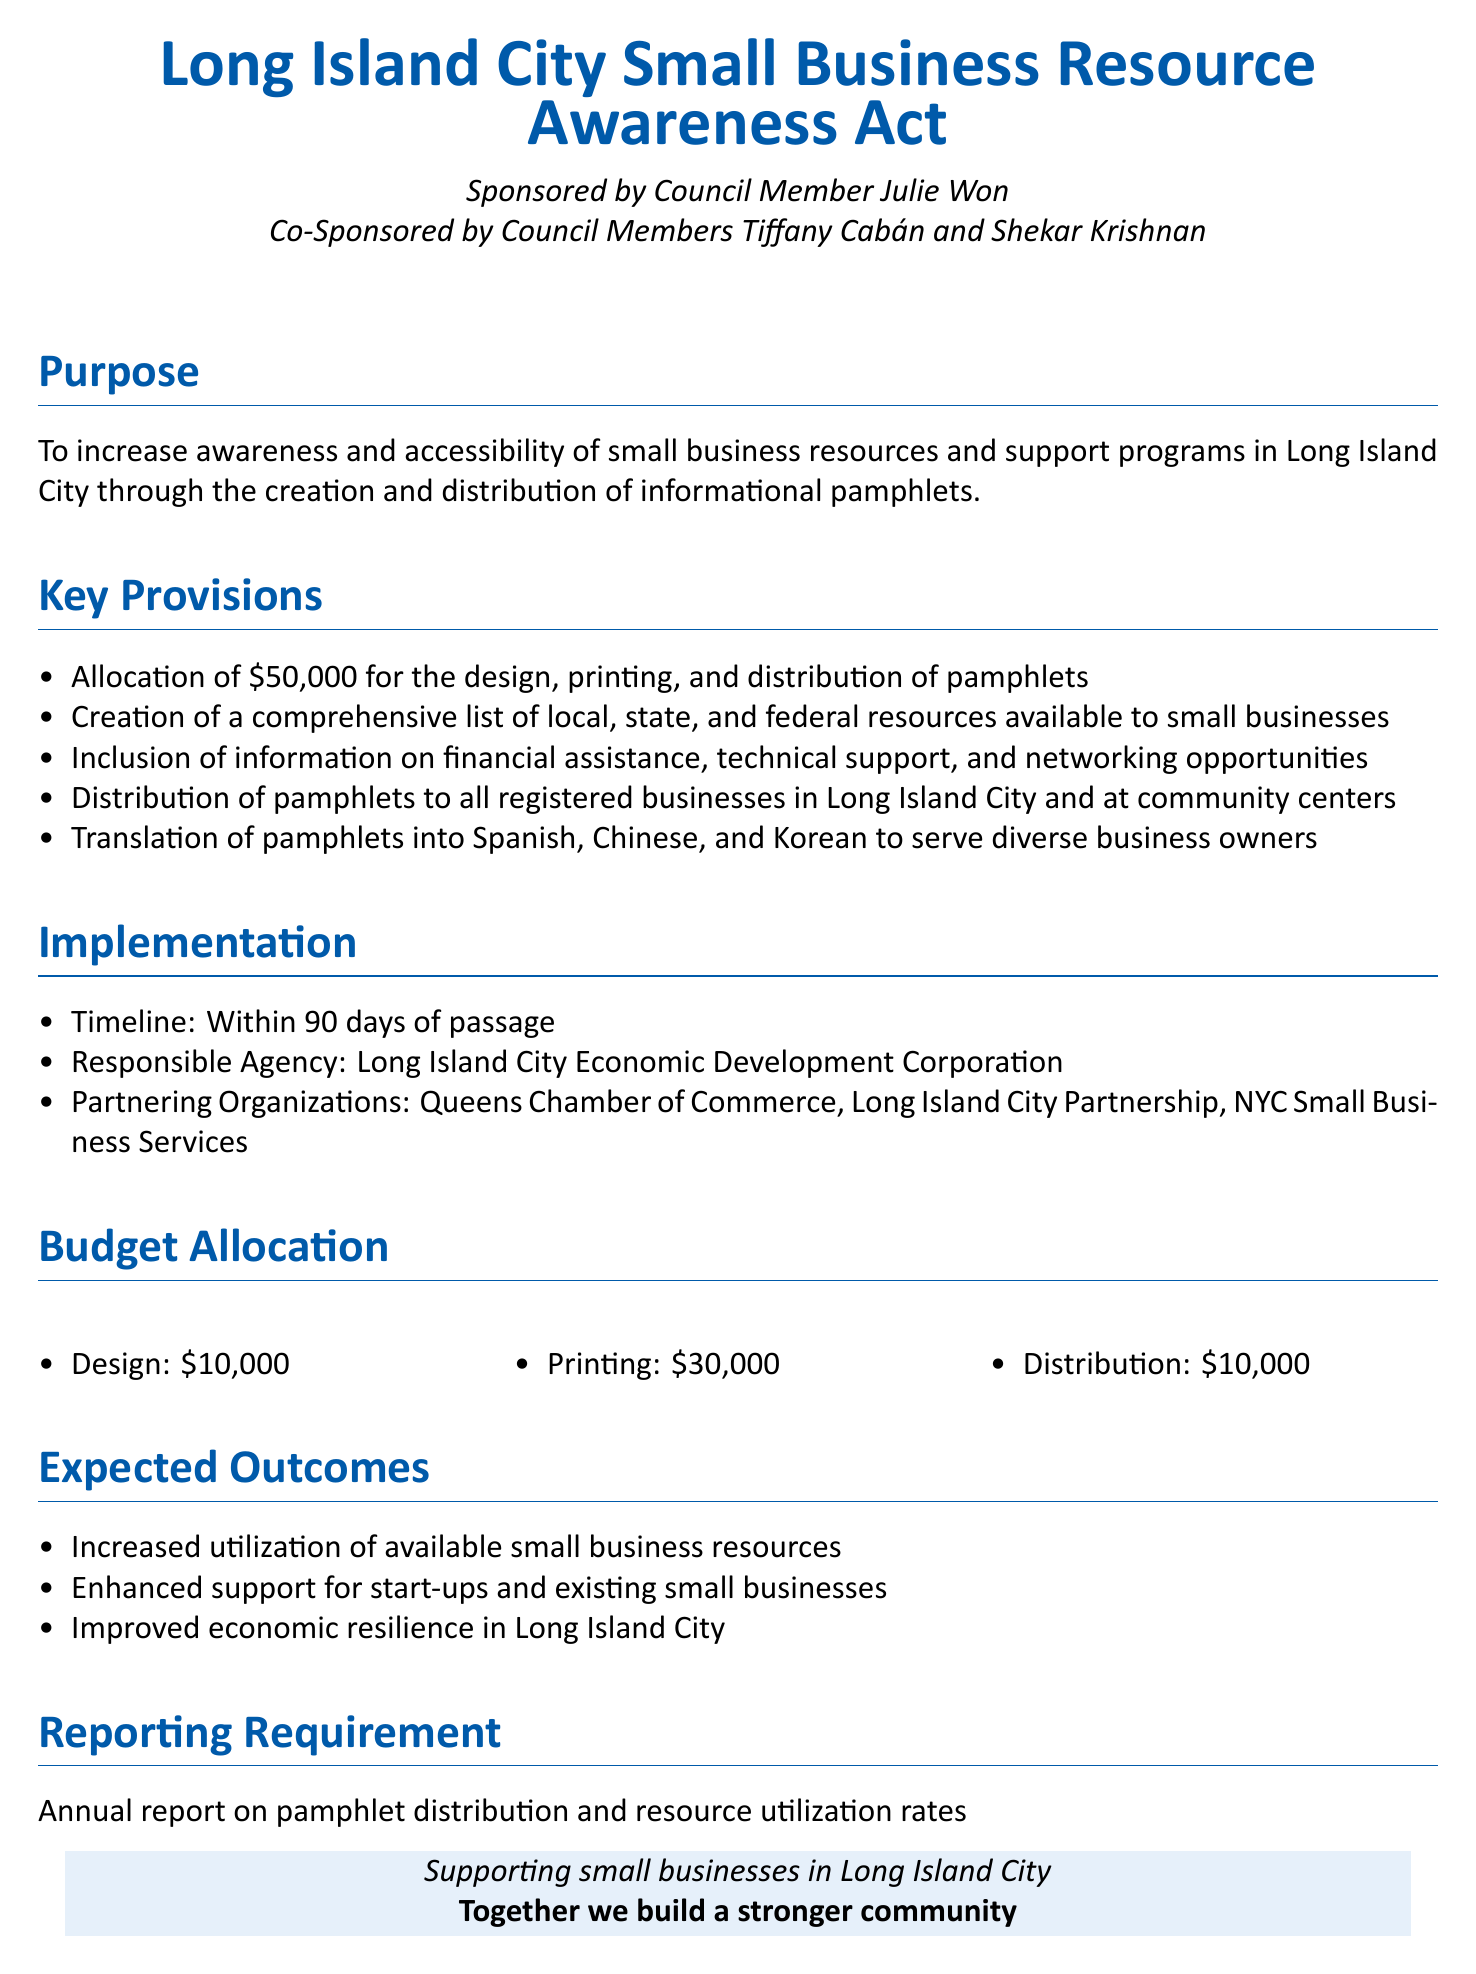What is the purpose of the bill? The purpose of the bill is stated in the document's Purpose section, which aims to increase awareness and accessibility of small business resources and support programs in Long Island City through pamphlets.
Answer: Increase awareness and accessibility How much funding is allocated for this bill? The budget section specifies the total funding allocated for the design, printing, and distribution of pamphlets.
Answer: $50,000 What are the languages into which pamphlets will be translated? The Key Provisions section lists the languages for translation, which serve diverse business owners.
Answer: Spanish, Chinese, Korean Who is the responsible agency for the implementation? The Implementation section identifies the agency responsible for carrying out the bill.
Answer: Long Island City Economic Development Corporation What is the timeline for implementation? The Implementation section provides a specific period for when the pamphlets are expected to be distributed after the bill's passage.
Answer: Within 90 days What is the budget allocation for printing? The Budget Allocation section breaks down the costs, providing specific amounts designated for each category.
Answer: $30,000 What is the expected outcome related to economic resilience? The Expected Outcomes section specifies one of the anticipated benefits of the bill for Long Island City.
Answer: Improved economic resilience What report is required annually? The Reporting Requirement section indicates what kind of report is expected after implementing the bill.
Answer: Annual report on pamphlet distribution and resource utilization rates 